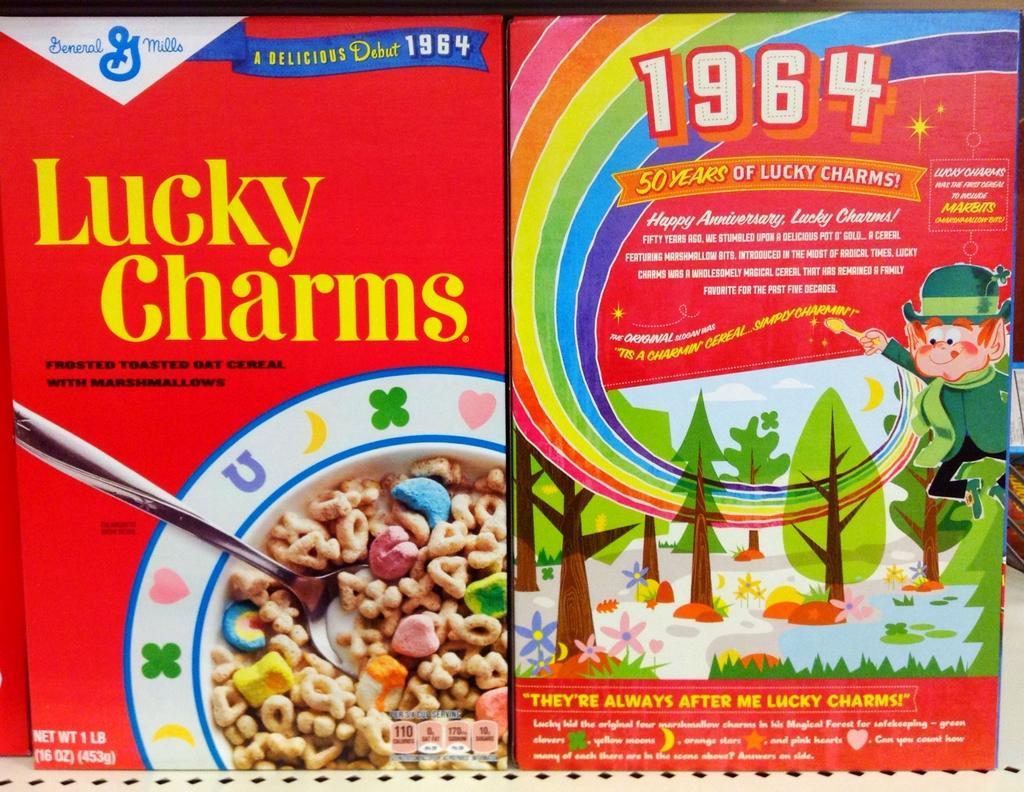What type of food packaging can be seen in the image? There are two cereal boxes in the image. What do the cereal boxes have on them? The cereal boxes have graphic images on them. How are the cereal boxes positioned in the image? The cereal boxes are placed beside each other. What type of lock is used to secure the cereal boxes in the image? There is no lock present on the cereal boxes in the image. What type of meal is being prepared using the cereal boxes in the image? The image does not show any meal preparation involving the cereal boxes. 